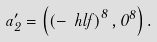<formula> <loc_0><loc_0><loc_500><loc_500>a _ { 2 } ^ { \prime } = \left ( \left ( - \ h l f \right ) ^ { 8 } , 0 ^ { 8 } \right ) .</formula> 